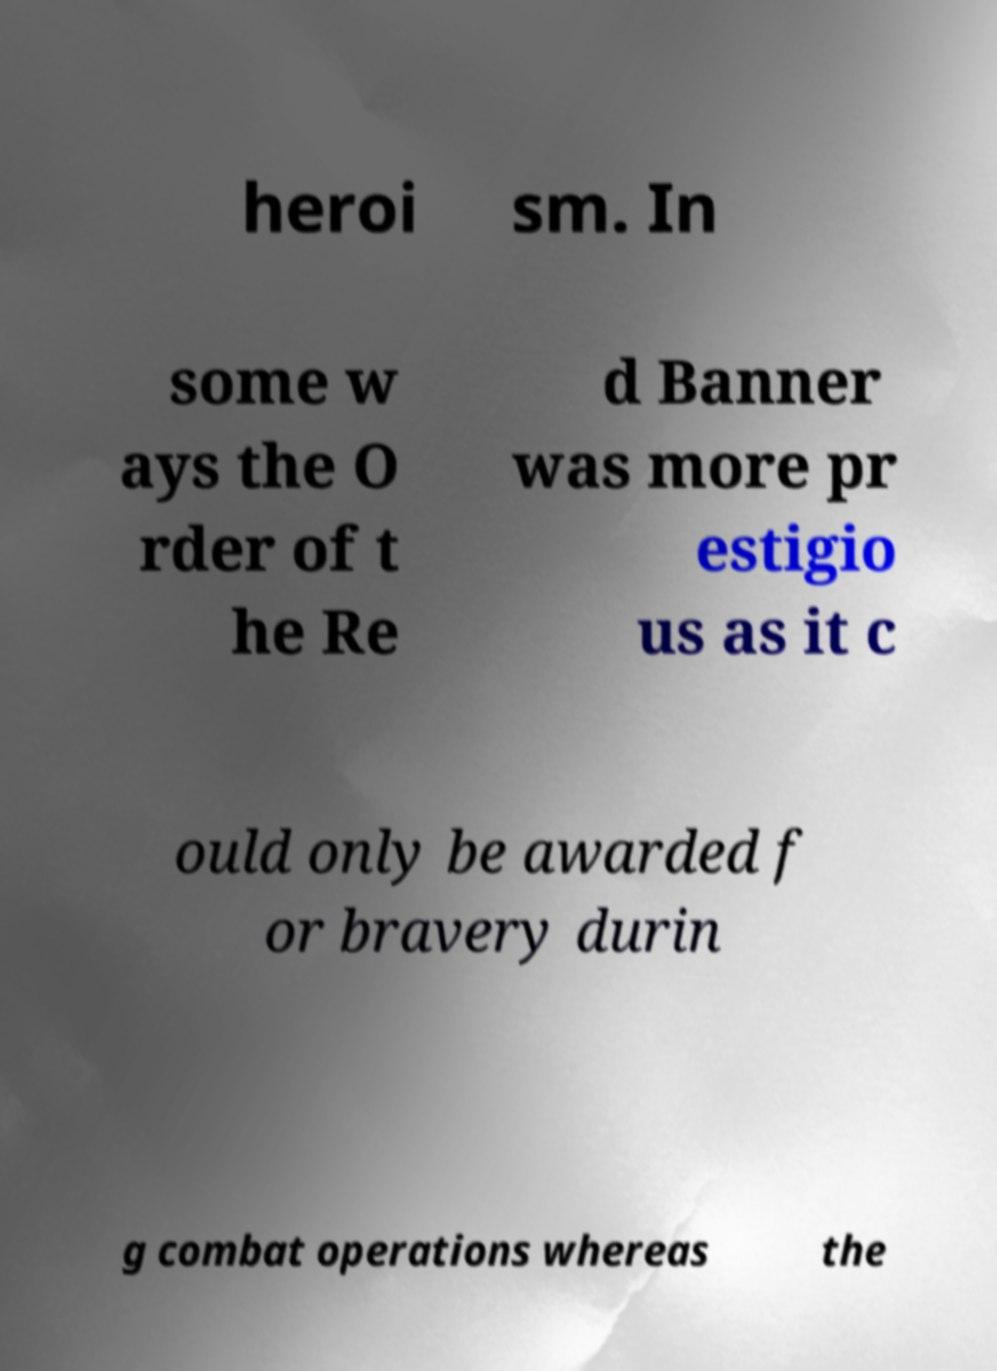Please identify and transcribe the text found in this image. heroi sm. In some w ays the O rder of t he Re d Banner was more pr estigio us as it c ould only be awarded f or bravery durin g combat operations whereas the 